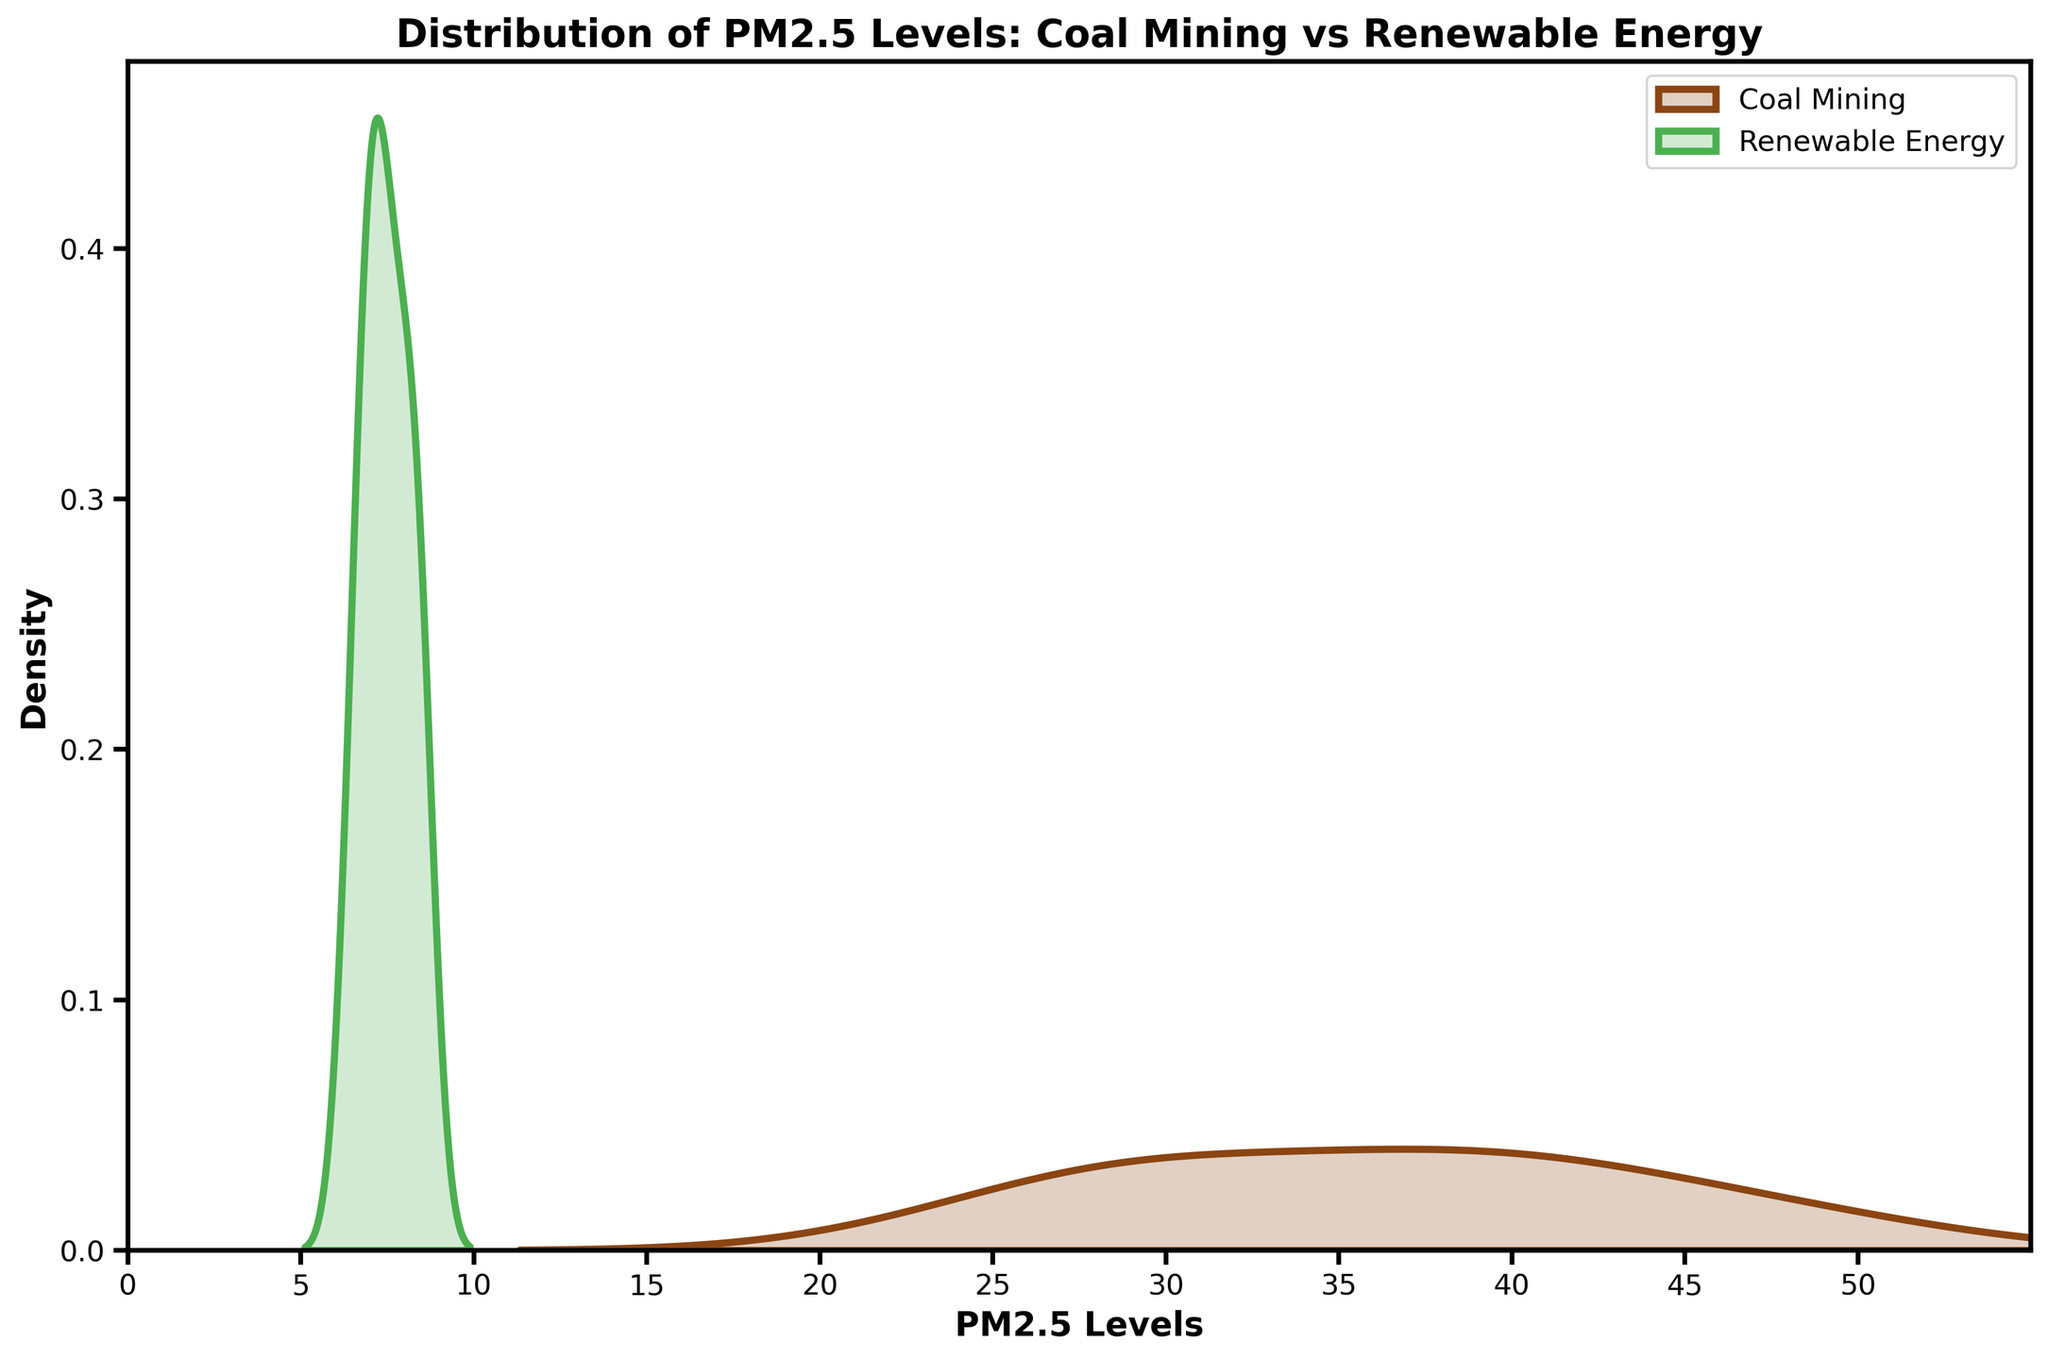What are the two types of regions compared in the plot? The plot depicts the distribution of PM2.5 levels for two types of regions: Coal Mining and Renewable Energy.
Answer: Coal Mining and Renewable Energy What color represents the PM2.5 distribution for Renewable Energy sites? The plot uses different colors for each region type. The distribution for Renewable Energy is shown in green.
Answer: Green Where is the peak of the PM2.5 density curve for Renewable Energy approximately located? The peak of the density curve represents the most common PM2.5 level. For Renewable Energy, the peak is located around 7-8.
Answer: 7-8 What is the approximate range of PM2.5 levels in Coal Mining regions depicted in the plot? Looking at the x-axis and the spread of the Coal Mining distribution, PM2.5 levels in Coal Mining regions range from approximately 25 to 50.
Answer: 25 to 50 How do the PM2.5 levels in Renewable Energy sites generally compare to those in Coal Mining regions? Comparing the density curves, PM2.5 levels in Renewable Energy sites are generally much lower than those in Coal Mining regions.
Answer: Lower Which type of region shows a wider spread in PM2.5 levels? The spread is indicated by the width of the density curve. The Coal Mining regions show a wider spread compared to Renewable Energy sites.
Answer: Coal Mining By how much is the PM2.5 level at the peak density for Coal Mining higher than that for Renewable Energy? Identify the peak density values for both types and calculate the difference. The peak density for Coal Mining is around 30-35, while for Renewable Energy it is around 7-8. The approximate difference is 23-27.
Answer: 23-27 What is the title of the plot? The title is located at the top of the plot and provides an overview of the visualized data.
Answer: Distribution of PM2.5 Levels: Coal Mining vs Renewable Energy Which region type has a sharper peak in the density curve, and what does it indicate? The Renewable Energy sites have a sharper peak, which indicates that the PM2.5 levels are more uniform and concentrated around a specific value.
Answer: Renewable Energy What can be inferred about the environmental impact of Coal Mining regions compared to Renewable Energy sites based on the plot? The higher and more spread out PM2.5 levels in Coal Mining regions suggest a higher and more variable level of particulate matter, indicating a potentially greater environmental impact compared to Renewable Energy sites.
Answer: Greater environmental impact in Coal Mining regions 